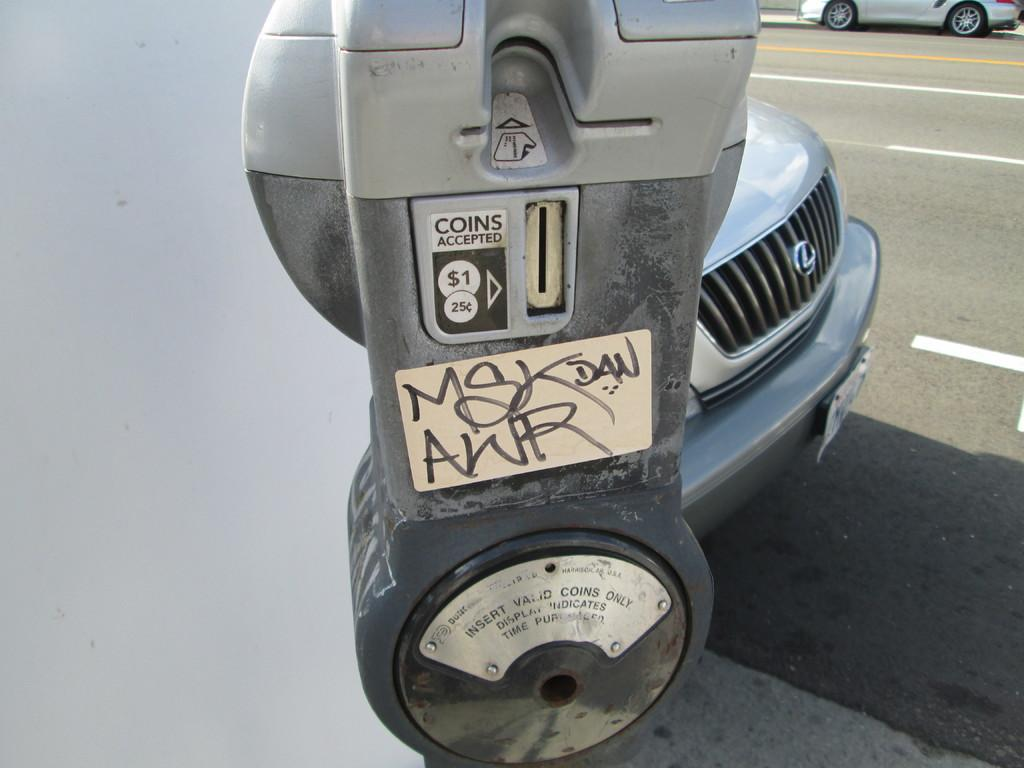<image>
Give a short and clear explanation of the subsequent image. A parking meter that has a slot that says coins accepted. 